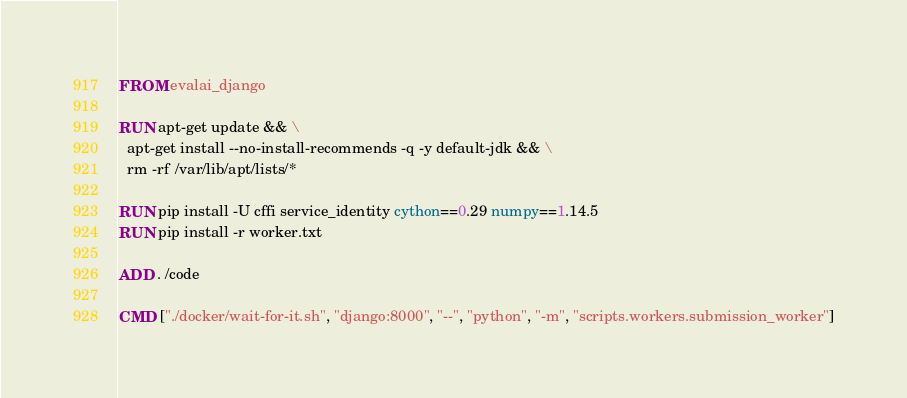Convert code to text. <code><loc_0><loc_0><loc_500><loc_500><_Dockerfile_>FROM evalai_django

RUN apt-get update && \
  apt-get install --no-install-recommends -q -y default-jdk && \
  rm -rf /var/lib/apt/lists/*

RUN pip install -U cffi service_identity cython==0.29 numpy==1.14.5
RUN pip install -r worker.txt

ADD . /code

CMD ["./docker/wait-for-it.sh", "django:8000", "--", "python", "-m", "scripts.workers.submission_worker"]
</code> 